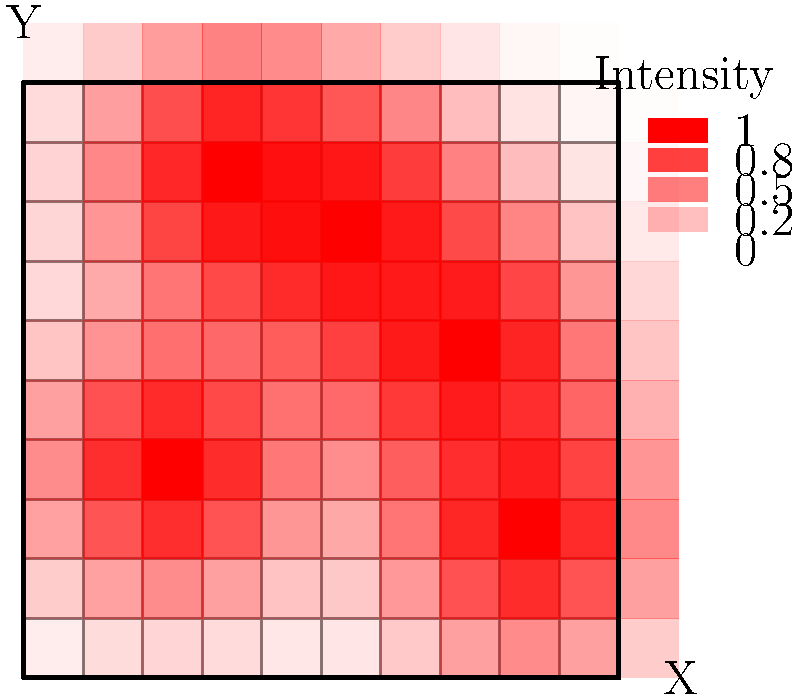As a data scientist specializing in GIS, you've been tasked with creating a heat map to visualize crime hotspots in a city. The map above shows the result of your analysis. Based on this heat map, which area of the city (represented by its coordinates) appears to have the highest concentration of criminal activity? To determine the area with the highest concentration of criminal activity, we need to analyze the heat map:

1. The heat map uses color intensity to represent the concentration of crime, with darker red areas indicating higher crime rates.

2. The map is divided into a 10x10 grid, with coordinates ranging from (0,0) to (10,10).

3. We can observe several hotspots on the map, but we need to identify the most intense one.

4. By examining the color intensity, we can see that the darkest red area is located near the center-top of the map.

5. This hotspot is approximately centered at coordinates (5,7).

6. Other notable hotspots exist, such as at (2,3) and (7,5), but they appear less intense than the one at (5,7).

7. The legend on the right side of the map confirms that the darkest red color corresponds to the highest intensity (1.0).

Therefore, based on this heat map visualization, the area with the highest concentration of criminal activity appears to be centered around the coordinates (5,7).
Answer: (5,7) 